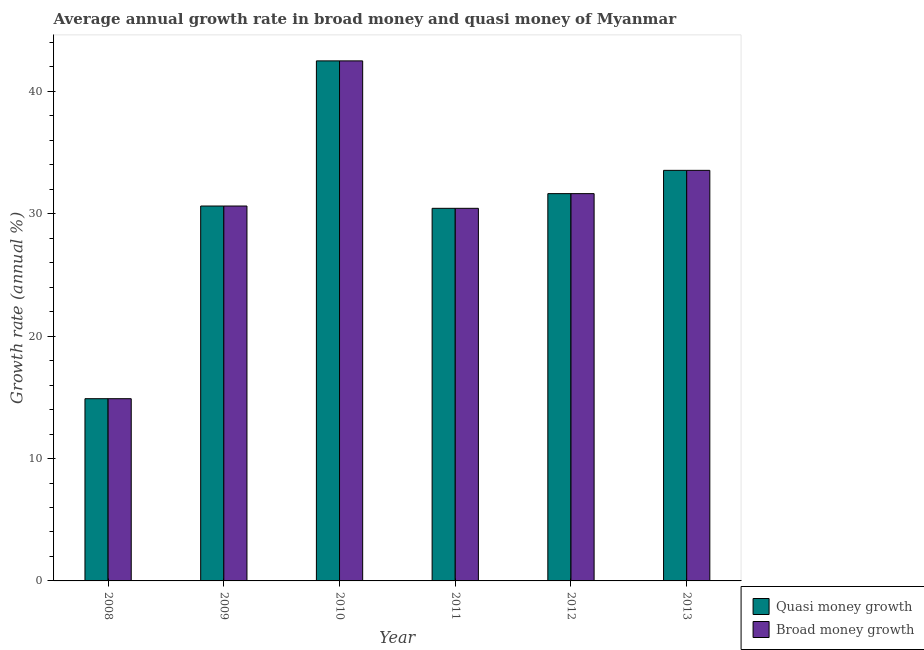What is the label of the 6th group of bars from the left?
Your answer should be compact. 2013. What is the annual growth rate in broad money in 2013?
Your answer should be compact. 33.55. Across all years, what is the maximum annual growth rate in quasi money?
Your answer should be very brief. 42.5. Across all years, what is the minimum annual growth rate in quasi money?
Make the answer very short. 14.89. In which year was the annual growth rate in quasi money maximum?
Give a very brief answer. 2010. In which year was the annual growth rate in quasi money minimum?
Offer a very short reply. 2008. What is the total annual growth rate in broad money in the graph?
Keep it short and to the point. 183.68. What is the difference between the annual growth rate in broad money in 2011 and that in 2012?
Ensure brevity in your answer.  -1.2. What is the difference between the annual growth rate in quasi money in 2008 and the annual growth rate in broad money in 2010?
Offer a very short reply. -27.61. What is the average annual growth rate in quasi money per year?
Make the answer very short. 30.61. What is the ratio of the annual growth rate in quasi money in 2008 to that in 2013?
Give a very brief answer. 0.44. Is the annual growth rate in broad money in 2012 less than that in 2013?
Offer a terse response. Yes. Is the difference between the annual growth rate in quasi money in 2010 and 2011 greater than the difference between the annual growth rate in broad money in 2010 and 2011?
Make the answer very short. No. What is the difference between the highest and the second highest annual growth rate in quasi money?
Make the answer very short. 8.95. What is the difference between the highest and the lowest annual growth rate in broad money?
Keep it short and to the point. 27.61. What does the 1st bar from the left in 2012 represents?
Your response must be concise. Quasi money growth. What does the 1st bar from the right in 2011 represents?
Provide a short and direct response. Broad money growth. How many bars are there?
Your answer should be very brief. 12. How many years are there in the graph?
Offer a very short reply. 6. What is the difference between two consecutive major ticks on the Y-axis?
Your answer should be very brief. 10. Does the graph contain any zero values?
Offer a very short reply. No. Where does the legend appear in the graph?
Your answer should be compact. Bottom right. What is the title of the graph?
Provide a short and direct response. Average annual growth rate in broad money and quasi money of Myanmar. Does "Working capital" appear as one of the legend labels in the graph?
Ensure brevity in your answer.  No. What is the label or title of the Y-axis?
Your answer should be compact. Growth rate (annual %). What is the Growth rate (annual %) in Quasi money growth in 2008?
Ensure brevity in your answer.  14.89. What is the Growth rate (annual %) in Broad money growth in 2008?
Your answer should be compact. 14.89. What is the Growth rate (annual %) of Quasi money growth in 2009?
Your answer should be very brief. 30.64. What is the Growth rate (annual %) in Broad money growth in 2009?
Ensure brevity in your answer.  30.64. What is the Growth rate (annual %) of Quasi money growth in 2010?
Your answer should be compact. 42.5. What is the Growth rate (annual %) in Broad money growth in 2010?
Your response must be concise. 42.5. What is the Growth rate (annual %) in Quasi money growth in 2011?
Give a very brief answer. 30.45. What is the Growth rate (annual %) of Broad money growth in 2011?
Provide a short and direct response. 30.45. What is the Growth rate (annual %) of Quasi money growth in 2012?
Your answer should be compact. 31.65. What is the Growth rate (annual %) of Broad money growth in 2012?
Offer a very short reply. 31.65. What is the Growth rate (annual %) of Quasi money growth in 2013?
Give a very brief answer. 33.55. What is the Growth rate (annual %) in Broad money growth in 2013?
Provide a succinct answer. 33.55. Across all years, what is the maximum Growth rate (annual %) in Quasi money growth?
Your answer should be compact. 42.5. Across all years, what is the maximum Growth rate (annual %) in Broad money growth?
Keep it short and to the point. 42.5. Across all years, what is the minimum Growth rate (annual %) of Quasi money growth?
Your answer should be compact. 14.89. Across all years, what is the minimum Growth rate (annual %) in Broad money growth?
Provide a short and direct response. 14.89. What is the total Growth rate (annual %) of Quasi money growth in the graph?
Give a very brief answer. 183.68. What is the total Growth rate (annual %) of Broad money growth in the graph?
Give a very brief answer. 183.68. What is the difference between the Growth rate (annual %) of Quasi money growth in 2008 and that in 2009?
Make the answer very short. -15.75. What is the difference between the Growth rate (annual %) in Broad money growth in 2008 and that in 2009?
Keep it short and to the point. -15.75. What is the difference between the Growth rate (annual %) in Quasi money growth in 2008 and that in 2010?
Your answer should be very brief. -27.61. What is the difference between the Growth rate (annual %) in Broad money growth in 2008 and that in 2010?
Keep it short and to the point. -27.61. What is the difference between the Growth rate (annual %) of Quasi money growth in 2008 and that in 2011?
Provide a short and direct response. -15.56. What is the difference between the Growth rate (annual %) in Broad money growth in 2008 and that in 2011?
Provide a short and direct response. -15.56. What is the difference between the Growth rate (annual %) of Quasi money growth in 2008 and that in 2012?
Make the answer very short. -16.76. What is the difference between the Growth rate (annual %) of Broad money growth in 2008 and that in 2012?
Provide a short and direct response. -16.76. What is the difference between the Growth rate (annual %) of Quasi money growth in 2008 and that in 2013?
Keep it short and to the point. -18.66. What is the difference between the Growth rate (annual %) of Broad money growth in 2008 and that in 2013?
Your answer should be compact. -18.66. What is the difference between the Growth rate (annual %) of Quasi money growth in 2009 and that in 2010?
Your answer should be very brief. -11.86. What is the difference between the Growth rate (annual %) in Broad money growth in 2009 and that in 2010?
Ensure brevity in your answer.  -11.86. What is the difference between the Growth rate (annual %) in Quasi money growth in 2009 and that in 2011?
Offer a very short reply. 0.19. What is the difference between the Growth rate (annual %) of Broad money growth in 2009 and that in 2011?
Make the answer very short. 0.19. What is the difference between the Growth rate (annual %) in Quasi money growth in 2009 and that in 2012?
Keep it short and to the point. -1.01. What is the difference between the Growth rate (annual %) of Broad money growth in 2009 and that in 2012?
Offer a terse response. -1.01. What is the difference between the Growth rate (annual %) in Quasi money growth in 2009 and that in 2013?
Offer a terse response. -2.92. What is the difference between the Growth rate (annual %) in Broad money growth in 2009 and that in 2013?
Give a very brief answer. -2.92. What is the difference between the Growth rate (annual %) in Quasi money growth in 2010 and that in 2011?
Keep it short and to the point. 12.05. What is the difference between the Growth rate (annual %) in Broad money growth in 2010 and that in 2011?
Make the answer very short. 12.05. What is the difference between the Growth rate (annual %) of Quasi money growth in 2010 and that in 2012?
Offer a terse response. 10.85. What is the difference between the Growth rate (annual %) of Broad money growth in 2010 and that in 2012?
Give a very brief answer. 10.85. What is the difference between the Growth rate (annual %) in Quasi money growth in 2010 and that in 2013?
Make the answer very short. 8.95. What is the difference between the Growth rate (annual %) of Broad money growth in 2010 and that in 2013?
Your answer should be very brief. 8.95. What is the difference between the Growth rate (annual %) in Quasi money growth in 2011 and that in 2012?
Offer a very short reply. -1.2. What is the difference between the Growth rate (annual %) of Broad money growth in 2011 and that in 2012?
Make the answer very short. -1.2. What is the difference between the Growth rate (annual %) in Quasi money growth in 2011 and that in 2013?
Give a very brief answer. -3.1. What is the difference between the Growth rate (annual %) in Broad money growth in 2011 and that in 2013?
Ensure brevity in your answer.  -3.1. What is the difference between the Growth rate (annual %) in Quasi money growth in 2012 and that in 2013?
Offer a very short reply. -1.9. What is the difference between the Growth rate (annual %) of Broad money growth in 2012 and that in 2013?
Your answer should be very brief. -1.9. What is the difference between the Growth rate (annual %) in Quasi money growth in 2008 and the Growth rate (annual %) in Broad money growth in 2009?
Your answer should be compact. -15.75. What is the difference between the Growth rate (annual %) of Quasi money growth in 2008 and the Growth rate (annual %) of Broad money growth in 2010?
Offer a terse response. -27.61. What is the difference between the Growth rate (annual %) of Quasi money growth in 2008 and the Growth rate (annual %) of Broad money growth in 2011?
Your response must be concise. -15.56. What is the difference between the Growth rate (annual %) of Quasi money growth in 2008 and the Growth rate (annual %) of Broad money growth in 2012?
Offer a very short reply. -16.76. What is the difference between the Growth rate (annual %) of Quasi money growth in 2008 and the Growth rate (annual %) of Broad money growth in 2013?
Provide a succinct answer. -18.66. What is the difference between the Growth rate (annual %) in Quasi money growth in 2009 and the Growth rate (annual %) in Broad money growth in 2010?
Your answer should be very brief. -11.86. What is the difference between the Growth rate (annual %) of Quasi money growth in 2009 and the Growth rate (annual %) of Broad money growth in 2011?
Your response must be concise. 0.19. What is the difference between the Growth rate (annual %) in Quasi money growth in 2009 and the Growth rate (annual %) in Broad money growth in 2012?
Make the answer very short. -1.01. What is the difference between the Growth rate (annual %) in Quasi money growth in 2009 and the Growth rate (annual %) in Broad money growth in 2013?
Your response must be concise. -2.92. What is the difference between the Growth rate (annual %) of Quasi money growth in 2010 and the Growth rate (annual %) of Broad money growth in 2011?
Your response must be concise. 12.05. What is the difference between the Growth rate (annual %) of Quasi money growth in 2010 and the Growth rate (annual %) of Broad money growth in 2012?
Provide a short and direct response. 10.85. What is the difference between the Growth rate (annual %) in Quasi money growth in 2010 and the Growth rate (annual %) in Broad money growth in 2013?
Your answer should be compact. 8.95. What is the difference between the Growth rate (annual %) in Quasi money growth in 2011 and the Growth rate (annual %) in Broad money growth in 2012?
Make the answer very short. -1.2. What is the difference between the Growth rate (annual %) of Quasi money growth in 2011 and the Growth rate (annual %) of Broad money growth in 2013?
Make the answer very short. -3.1. What is the difference between the Growth rate (annual %) of Quasi money growth in 2012 and the Growth rate (annual %) of Broad money growth in 2013?
Your answer should be compact. -1.9. What is the average Growth rate (annual %) in Quasi money growth per year?
Offer a terse response. 30.61. What is the average Growth rate (annual %) in Broad money growth per year?
Provide a short and direct response. 30.61. In the year 2011, what is the difference between the Growth rate (annual %) in Quasi money growth and Growth rate (annual %) in Broad money growth?
Your response must be concise. 0. In the year 2013, what is the difference between the Growth rate (annual %) in Quasi money growth and Growth rate (annual %) in Broad money growth?
Keep it short and to the point. 0. What is the ratio of the Growth rate (annual %) in Quasi money growth in 2008 to that in 2009?
Your answer should be very brief. 0.49. What is the ratio of the Growth rate (annual %) in Broad money growth in 2008 to that in 2009?
Provide a short and direct response. 0.49. What is the ratio of the Growth rate (annual %) of Quasi money growth in 2008 to that in 2010?
Give a very brief answer. 0.35. What is the ratio of the Growth rate (annual %) in Broad money growth in 2008 to that in 2010?
Ensure brevity in your answer.  0.35. What is the ratio of the Growth rate (annual %) of Quasi money growth in 2008 to that in 2011?
Your response must be concise. 0.49. What is the ratio of the Growth rate (annual %) of Broad money growth in 2008 to that in 2011?
Your answer should be very brief. 0.49. What is the ratio of the Growth rate (annual %) in Quasi money growth in 2008 to that in 2012?
Keep it short and to the point. 0.47. What is the ratio of the Growth rate (annual %) of Broad money growth in 2008 to that in 2012?
Provide a succinct answer. 0.47. What is the ratio of the Growth rate (annual %) of Quasi money growth in 2008 to that in 2013?
Your answer should be compact. 0.44. What is the ratio of the Growth rate (annual %) in Broad money growth in 2008 to that in 2013?
Give a very brief answer. 0.44. What is the ratio of the Growth rate (annual %) of Quasi money growth in 2009 to that in 2010?
Your answer should be very brief. 0.72. What is the ratio of the Growth rate (annual %) of Broad money growth in 2009 to that in 2010?
Provide a succinct answer. 0.72. What is the ratio of the Growth rate (annual %) in Quasi money growth in 2009 to that in 2011?
Provide a short and direct response. 1.01. What is the ratio of the Growth rate (annual %) in Broad money growth in 2009 to that in 2011?
Give a very brief answer. 1.01. What is the ratio of the Growth rate (annual %) in Quasi money growth in 2009 to that in 2012?
Offer a very short reply. 0.97. What is the ratio of the Growth rate (annual %) of Quasi money growth in 2009 to that in 2013?
Offer a very short reply. 0.91. What is the ratio of the Growth rate (annual %) in Broad money growth in 2009 to that in 2013?
Ensure brevity in your answer.  0.91. What is the ratio of the Growth rate (annual %) of Quasi money growth in 2010 to that in 2011?
Your answer should be very brief. 1.4. What is the ratio of the Growth rate (annual %) in Broad money growth in 2010 to that in 2011?
Your response must be concise. 1.4. What is the ratio of the Growth rate (annual %) of Quasi money growth in 2010 to that in 2012?
Your answer should be very brief. 1.34. What is the ratio of the Growth rate (annual %) of Broad money growth in 2010 to that in 2012?
Provide a short and direct response. 1.34. What is the ratio of the Growth rate (annual %) of Quasi money growth in 2010 to that in 2013?
Give a very brief answer. 1.27. What is the ratio of the Growth rate (annual %) in Broad money growth in 2010 to that in 2013?
Give a very brief answer. 1.27. What is the ratio of the Growth rate (annual %) of Quasi money growth in 2011 to that in 2012?
Your answer should be very brief. 0.96. What is the ratio of the Growth rate (annual %) in Broad money growth in 2011 to that in 2012?
Keep it short and to the point. 0.96. What is the ratio of the Growth rate (annual %) of Quasi money growth in 2011 to that in 2013?
Your answer should be compact. 0.91. What is the ratio of the Growth rate (annual %) in Broad money growth in 2011 to that in 2013?
Provide a succinct answer. 0.91. What is the ratio of the Growth rate (annual %) of Quasi money growth in 2012 to that in 2013?
Keep it short and to the point. 0.94. What is the ratio of the Growth rate (annual %) of Broad money growth in 2012 to that in 2013?
Your response must be concise. 0.94. What is the difference between the highest and the second highest Growth rate (annual %) of Quasi money growth?
Offer a very short reply. 8.95. What is the difference between the highest and the second highest Growth rate (annual %) of Broad money growth?
Keep it short and to the point. 8.95. What is the difference between the highest and the lowest Growth rate (annual %) of Quasi money growth?
Ensure brevity in your answer.  27.61. What is the difference between the highest and the lowest Growth rate (annual %) in Broad money growth?
Keep it short and to the point. 27.61. 